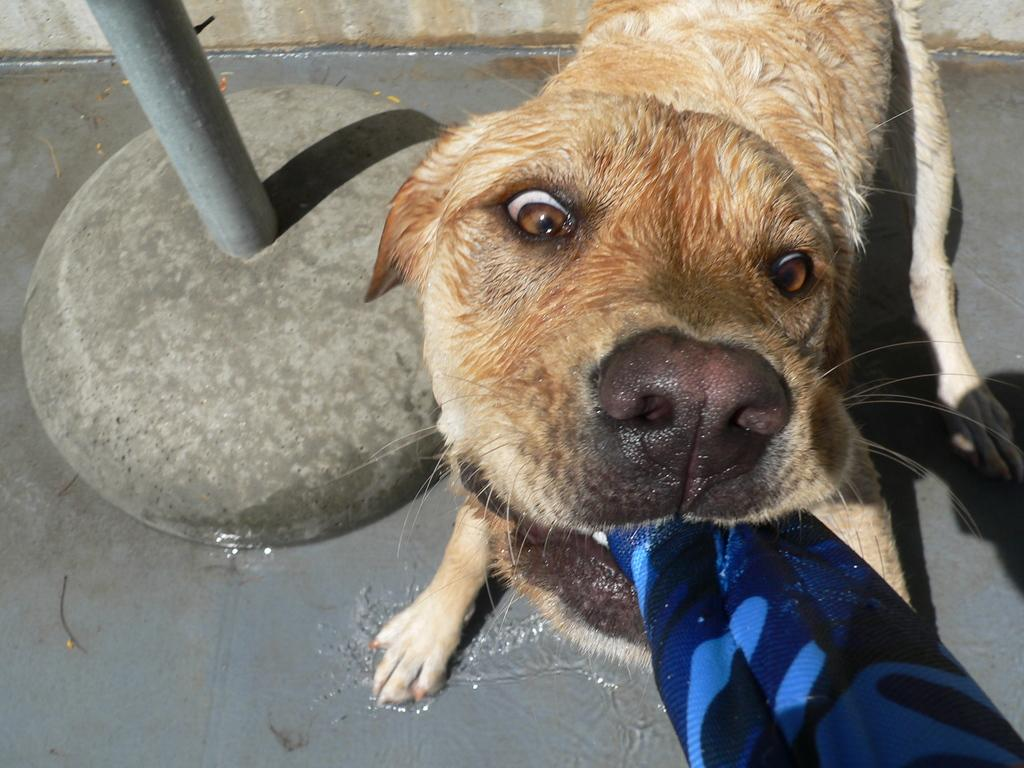What type of animal is in the image? There is a dog in the image. What is the dog doing with its mouth? The dog is holding a cloth in its mouth. What can be seen in the background of the image? There is a pole in the image. What is the condition of the ground in the image? There is water on the ground in the image. How many houses are visible in the image? There are no houses visible in the image; it features a dog holding a cloth and a pole in the background. What type of match is being used by the dog in the image? There is no match present in the image; the dog is holding a cloth in its mouth. 